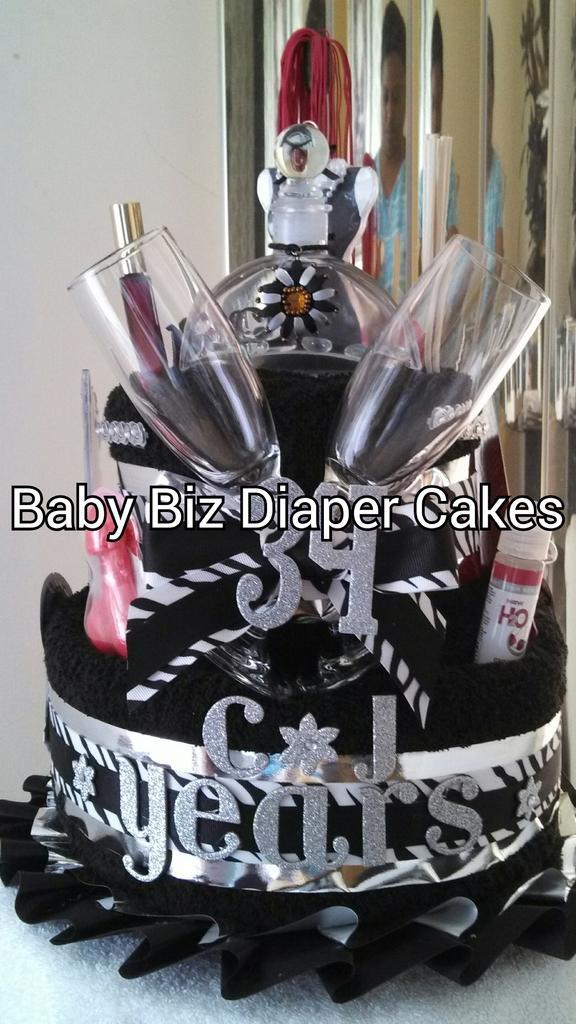Can you describe this image briefly? In this image I can see an object which is in black and silver color. Background I can see a wall in white color. 